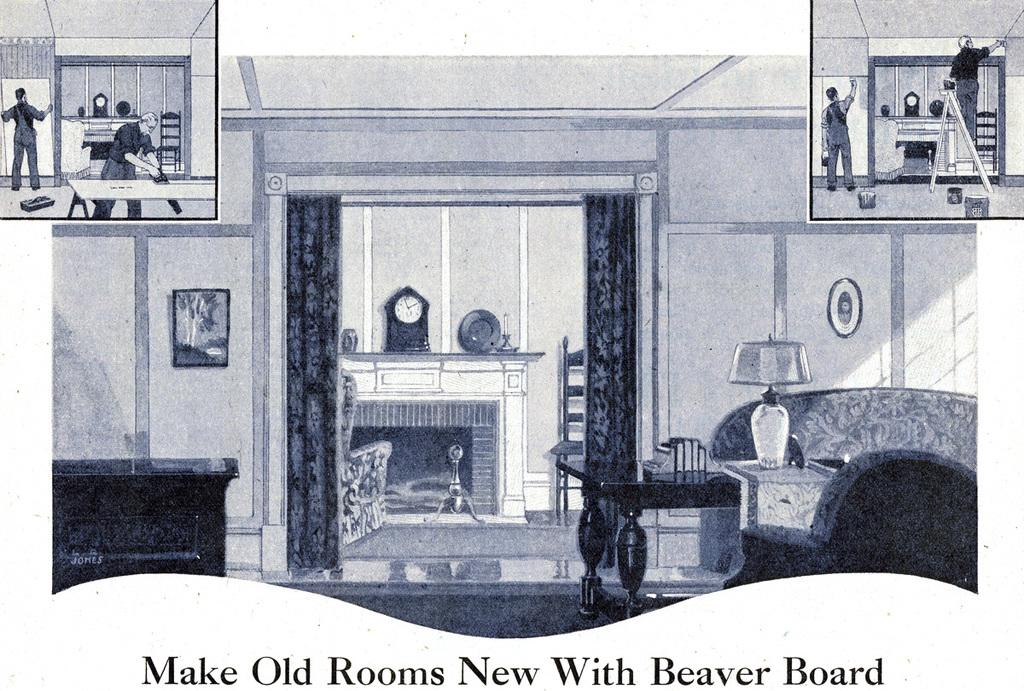What is depicted on the paper in the image? The paper contains a drawing of a wall, curtains, a photo frame, a clock, a chair, a sofa, a lamp, and tables. Can you describe the contents of the drawing in more detail? The drawing includes a wall, curtains hanging on the wall, a photo frame on the wall, a clock on the wall, a chair, a sofa, a lamp, and tables. What type of hat is the aunt wearing in the image? There is no aunt or hat present in the image; it only contains a drawing on a paper. 